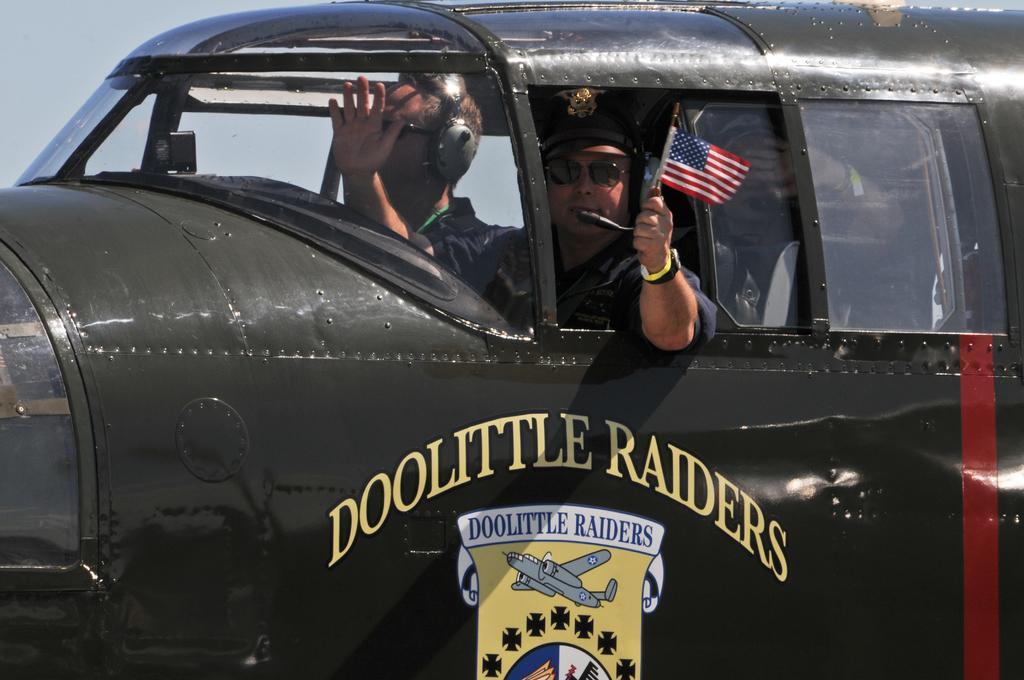Please provide a concise description of this image. In this picture we can see some people are traveling in a vehicle, one person is holding the flag. 